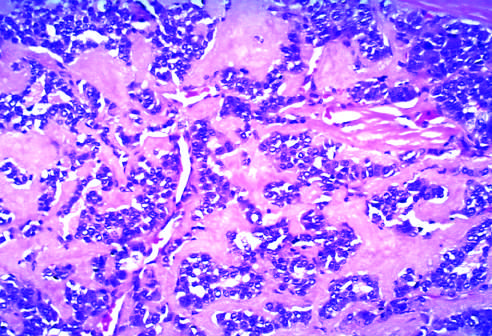do these tumors contain amyloid, visible here as homogeneous extracellular material, derived from calcitonin molecules secreted by the neoplastic cells?
Answer the question using a single word or phrase. Yes 